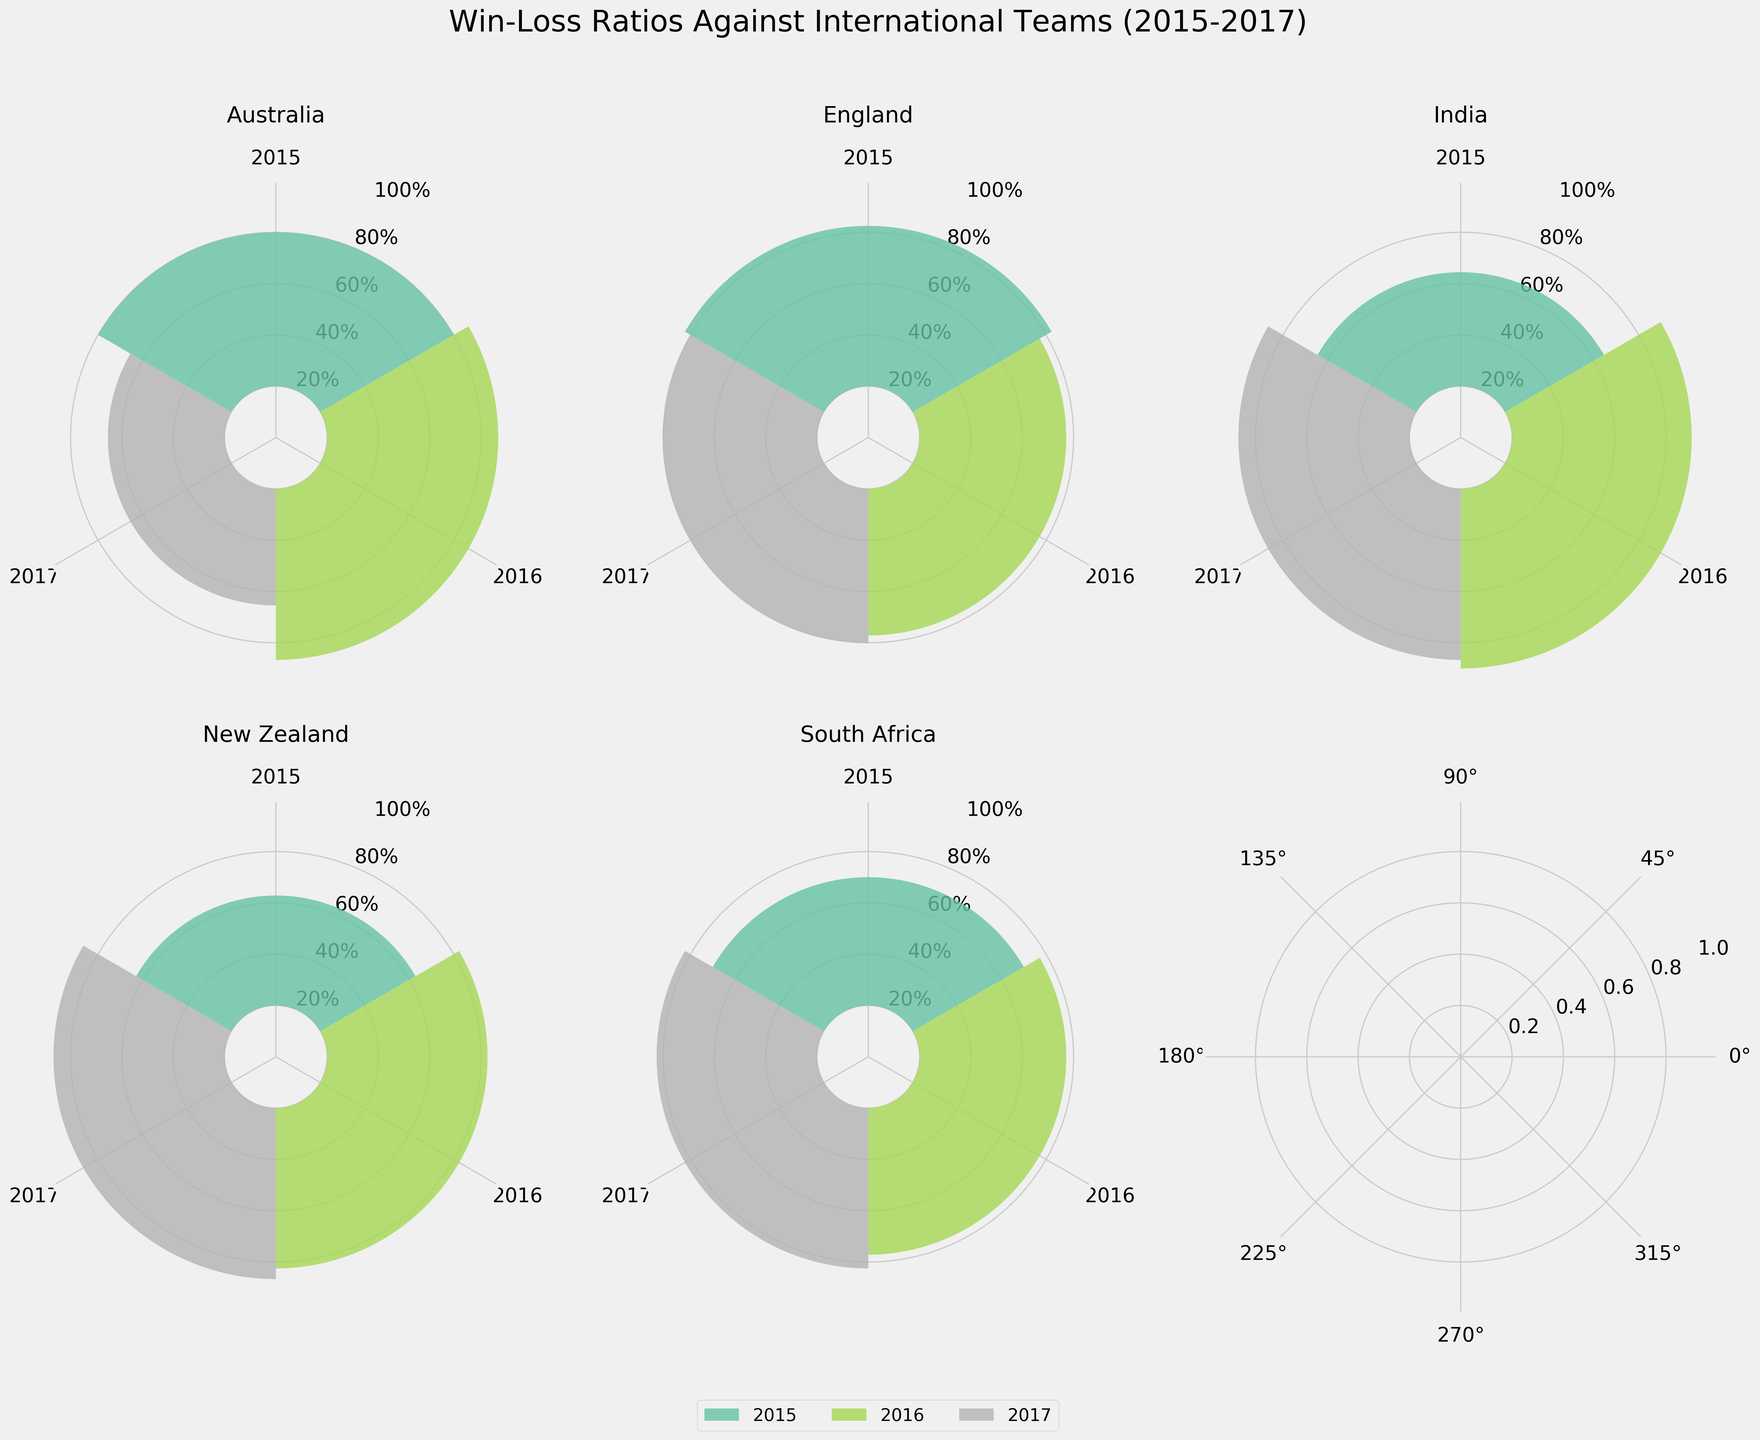What's the title of the subplot figure? The title of the subplot figure is typically found at the top of the visualization. The title in this case helps to understand the overall theme and purpose of the figure. By looking at the figure, you can see that the title is "Win-Loss Ratios Against International Teams (2015-2017)".
Answer: Win-Loss Ratios Against International Teams (2015-2017) Which team had the highest win ratio in 2016? To determine the highest win ratio, observe the plot corresponding to year 2016 for each team. The win ratio is depicted as the height of the bar for that year. Comparing all teams, identify the highest bar. The team "India" has the highest win ratio in 2016 with a higher bar compared to the other teams for that year.
Answer: India How does the win ratio of England in 2015 compare to their win ratio in 2016? Look at the subplot for England and compare the heights of the bars for the years 2015 and 2016. The win ratio is depicted by the height of the bar. In 2015, the bar is slightly higher than in 2016, indicating a better win ratio in 2015.
Answer: Higher in 2015 What is the approximate win ratio of South Africa in 2017? Focus on the subplot for South Africa and identify the bar for the year 2017. The win ratio can be estimated by looking at the height of the bar relative to the y-axis labels. The bar reaches close to the 60% mark, indicating a win ratio of approximately 60%.
Answer: Approximately 60% Did New Zealand improve their win ratio from 2015 to 2017? Check the subplot for New Zealand and compare the bars for the years 2015 and 2017. The win ratio is shown as the bar's height. By comparing these two bars, you can see that the bar for 2017 is higher than that for 2015, indicating an improvement in the win ratio over the years.
Answer: Yes For which years is Australia's win ratio less than 50%? In the subplot for Australia, find the bars that do not reach the halfway mark on the y-axis (50%). These bars represent the years where the win ratio is less than 50%. The year 2017 has a bar that does not reach this threshold, indicating a win ratio below 50%.
Answer: 2017 What percentage of matches did India win in 2015? Look at the subplot for India and find the bar for 2015. The height of this bar relative to the y-axis will give you the win ratio percentage. The bar for 2015 reaches approximately halfway (50%), which suggests that India won around 50% of their matches in that year.
Answer: About 50% Compare the win ratio of Australia and England in 2017. Which team had a better win ratio? By examining the subplots for both Australia and England for the year 2017, compare the heights of the bars. The win ratio is represented by the height of these bars. The bar for England is higher than the bar for Australia, indicating a better win ratio for England in 2017.
Answer: England had a better win ratio Which team exhibited the most consistent win ratio over the years 2015-2017? To find the most consistent team, observe the subplots for all teams across the years 2015-2017 and look for minimal variance in the heights of bars. South Africa's bars have the least variation, indicating consistent win ratios over the years.
Answer: South Africa 